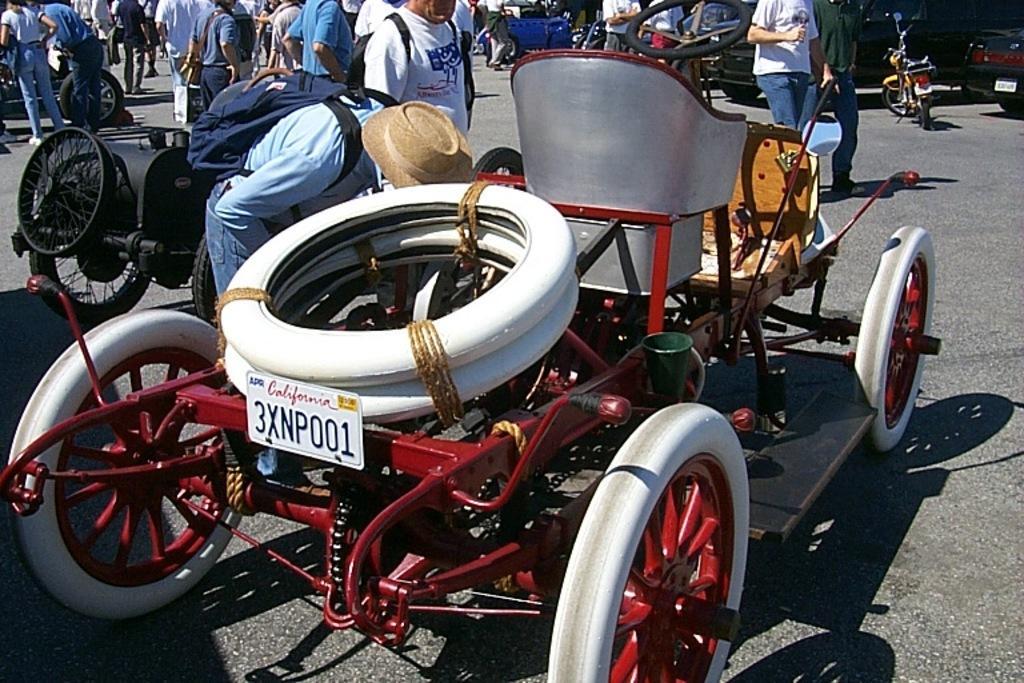Describe this image in one or two sentences. In this image I can see the group of people and few people are wearing bags. I can see few vehicles on the road. 